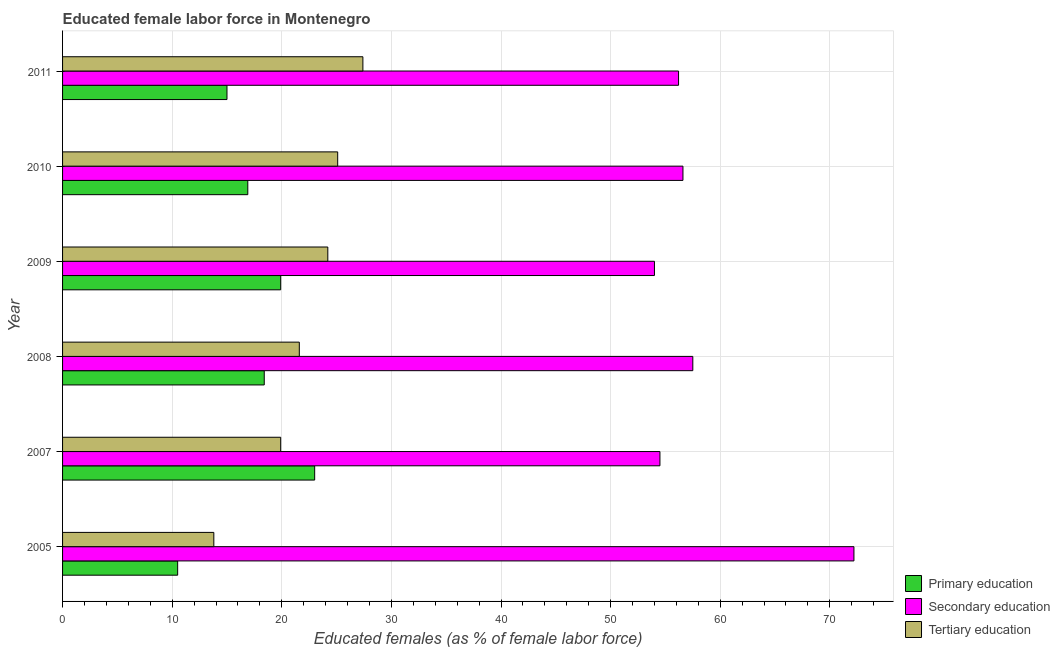How many different coloured bars are there?
Your answer should be compact. 3. How many bars are there on the 6th tick from the bottom?
Provide a succinct answer. 3. In how many cases, is the number of bars for a given year not equal to the number of legend labels?
Ensure brevity in your answer.  0. What is the percentage of female labor force who received tertiary education in 2005?
Provide a short and direct response. 13.8. Across all years, what is the maximum percentage of female labor force who received tertiary education?
Your response must be concise. 27.4. Across all years, what is the minimum percentage of female labor force who received secondary education?
Make the answer very short. 54. In which year was the percentage of female labor force who received secondary education minimum?
Provide a succinct answer. 2009. What is the total percentage of female labor force who received primary education in the graph?
Make the answer very short. 103.7. What is the difference between the percentage of female labor force who received tertiary education in 2005 and that in 2009?
Offer a very short reply. -10.4. What is the difference between the percentage of female labor force who received tertiary education in 2011 and the percentage of female labor force who received primary education in 2010?
Keep it short and to the point. 10.5. What is the average percentage of female labor force who received primary education per year?
Your answer should be compact. 17.28. In the year 2007, what is the difference between the percentage of female labor force who received primary education and percentage of female labor force who received tertiary education?
Offer a terse response. 3.1. Is the percentage of female labor force who received primary education in 2010 less than that in 2011?
Give a very brief answer. No. Is the difference between the percentage of female labor force who received tertiary education in 2007 and 2010 greater than the difference between the percentage of female labor force who received primary education in 2007 and 2010?
Your answer should be compact. No. What is the difference between the highest and the second highest percentage of female labor force who received primary education?
Keep it short and to the point. 3.1. What is the difference between the highest and the lowest percentage of female labor force who received secondary education?
Make the answer very short. 18.2. In how many years, is the percentage of female labor force who received secondary education greater than the average percentage of female labor force who received secondary education taken over all years?
Ensure brevity in your answer.  1. What does the 2nd bar from the top in 2008 represents?
Keep it short and to the point. Secondary education. What does the 2nd bar from the bottom in 2008 represents?
Provide a succinct answer. Secondary education. Is it the case that in every year, the sum of the percentage of female labor force who received primary education and percentage of female labor force who received secondary education is greater than the percentage of female labor force who received tertiary education?
Offer a very short reply. Yes. How many bars are there?
Offer a terse response. 18. Are all the bars in the graph horizontal?
Your answer should be compact. Yes. How many years are there in the graph?
Ensure brevity in your answer.  6. Are the values on the major ticks of X-axis written in scientific E-notation?
Keep it short and to the point. No. Does the graph contain grids?
Ensure brevity in your answer.  Yes. How are the legend labels stacked?
Give a very brief answer. Vertical. What is the title of the graph?
Offer a terse response. Educated female labor force in Montenegro. Does "Central government" appear as one of the legend labels in the graph?
Offer a very short reply. No. What is the label or title of the X-axis?
Make the answer very short. Educated females (as % of female labor force). What is the label or title of the Y-axis?
Give a very brief answer. Year. What is the Educated females (as % of female labor force) of Secondary education in 2005?
Give a very brief answer. 72.2. What is the Educated females (as % of female labor force) of Tertiary education in 2005?
Offer a terse response. 13.8. What is the Educated females (as % of female labor force) of Secondary education in 2007?
Give a very brief answer. 54.5. What is the Educated females (as % of female labor force) in Tertiary education in 2007?
Offer a very short reply. 19.9. What is the Educated females (as % of female labor force) of Primary education in 2008?
Provide a succinct answer. 18.4. What is the Educated females (as % of female labor force) of Secondary education in 2008?
Offer a very short reply. 57.5. What is the Educated females (as % of female labor force) in Tertiary education in 2008?
Your answer should be very brief. 21.6. What is the Educated females (as % of female labor force) of Primary education in 2009?
Your response must be concise. 19.9. What is the Educated females (as % of female labor force) in Secondary education in 2009?
Your answer should be compact. 54. What is the Educated females (as % of female labor force) of Tertiary education in 2009?
Provide a short and direct response. 24.2. What is the Educated females (as % of female labor force) of Primary education in 2010?
Provide a short and direct response. 16.9. What is the Educated females (as % of female labor force) in Secondary education in 2010?
Keep it short and to the point. 56.6. What is the Educated females (as % of female labor force) in Tertiary education in 2010?
Provide a succinct answer. 25.1. What is the Educated females (as % of female labor force) of Primary education in 2011?
Offer a very short reply. 15. What is the Educated females (as % of female labor force) of Secondary education in 2011?
Keep it short and to the point. 56.2. What is the Educated females (as % of female labor force) in Tertiary education in 2011?
Offer a terse response. 27.4. Across all years, what is the maximum Educated females (as % of female labor force) in Primary education?
Provide a succinct answer. 23. Across all years, what is the maximum Educated females (as % of female labor force) in Secondary education?
Provide a succinct answer. 72.2. Across all years, what is the maximum Educated females (as % of female labor force) of Tertiary education?
Ensure brevity in your answer.  27.4. Across all years, what is the minimum Educated females (as % of female labor force) in Primary education?
Provide a short and direct response. 10.5. Across all years, what is the minimum Educated females (as % of female labor force) in Tertiary education?
Provide a short and direct response. 13.8. What is the total Educated females (as % of female labor force) in Primary education in the graph?
Your answer should be very brief. 103.7. What is the total Educated females (as % of female labor force) of Secondary education in the graph?
Your answer should be very brief. 351. What is the total Educated females (as % of female labor force) in Tertiary education in the graph?
Keep it short and to the point. 132. What is the difference between the Educated females (as % of female labor force) in Primary education in 2005 and that in 2007?
Provide a short and direct response. -12.5. What is the difference between the Educated females (as % of female labor force) in Secondary education in 2005 and that in 2008?
Your response must be concise. 14.7. What is the difference between the Educated females (as % of female labor force) in Tertiary education in 2005 and that in 2008?
Offer a very short reply. -7.8. What is the difference between the Educated females (as % of female labor force) of Secondary education in 2005 and that in 2009?
Keep it short and to the point. 18.2. What is the difference between the Educated females (as % of female labor force) in Primary education in 2005 and that in 2010?
Your answer should be very brief. -6.4. What is the difference between the Educated females (as % of female labor force) in Secondary education in 2005 and that in 2010?
Your response must be concise. 15.6. What is the difference between the Educated females (as % of female labor force) in Tertiary education in 2005 and that in 2010?
Provide a succinct answer. -11.3. What is the difference between the Educated females (as % of female labor force) of Secondary education in 2005 and that in 2011?
Provide a succinct answer. 16. What is the difference between the Educated females (as % of female labor force) in Tertiary education in 2005 and that in 2011?
Offer a terse response. -13.6. What is the difference between the Educated females (as % of female labor force) of Primary education in 2007 and that in 2008?
Keep it short and to the point. 4.6. What is the difference between the Educated females (as % of female labor force) of Primary education in 2007 and that in 2009?
Offer a very short reply. 3.1. What is the difference between the Educated females (as % of female labor force) of Secondary education in 2007 and that in 2009?
Provide a succinct answer. 0.5. What is the difference between the Educated females (as % of female labor force) in Primary education in 2007 and that in 2010?
Keep it short and to the point. 6.1. What is the difference between the Educated females (as % of female labor force) of Secondary education in 2007 and that in 2010?
Your response must be concise. -2.1. What is the difference between the Educated females (as % of female labor force) in Secondary education in 2007 and that in 2011?
Give a very brief answer. -1.7. What is the difference between the Educated females (as % of female labor force) in Primary education in 2008 and that in 2009?
Your answer should be very brief. -1.5. What is the difference between the Educated females (as % of female labor force) in Secondary education in 2008 and that in 2009?
Provide a succinct answer. 3.5. What is the difference between the Educated females (as % of female labor force) in Primary education in 2008 and that in 2010?
Keep it short and to the point. 1.5. What is the difference between the Educated females (as % of female labor force) in Secondary education in 2008 and that in 2010?
Ensure brevity in your answer.  0.9. What is the difference between the Educated females (as % of female labor force) of Primary education in 2008 and that in 2011?
Offer a terse response. 3.4. What is the difference between the Educated females (as % of female labor force) in Tertiary education in 2008 and that in 2011?
Provide a succinct answer. -5.8. What is the difference between the Educated females (as % of female labor force) of Primary education in 2009 and that in 2010?
Offer a terse response. 3. What is the difference between the Educated females (as % of female labor force) of Secondary education in 2009 and that in 2010?
Give a very brief answer. -2.6. What is the difference between the Educated females (as % of female labor force) in Tertiary education in 2009 and that in 2010?
Offer a terse response. -0.9. What is the difference between the Educated females (as % of female labor force) of Tertiary education in 2009 and that in 2011?
Provide a succinct answer. -3.2. What is the difference between the Educated females (as % of female labor force) of Primary education in 2010 and that in 2011?
Keep it short and to the point. 1.9. What is the difference between the Educated females (as % of female labor force) in Secondary education in 2010 and that in 2011?
Your answer should be compact. 0.4. What is the difference between the Educated females (as % of female labor force) of Primary education in 2005 and the Educated females (as % of female labor force) of Secondary education in 2007?
Keep it short and to the point. -44. What is the difference between the Educated females (as % of female labor force) of Primary education in 2005 and the Educated females (as % of female labor force) of Tertiary education in 2007?
Your answer should be very brief. -9.4. What is the difference between the Educated females (as % of female labor force) in Secondary education in 2005 and the Educated females (as % of female labor force) in Tertiary education in 2007?
Your answer should be compact. 52.3. What is the difference between the Educated females (as % of female labor force) of Primary education in 2005 and the Educated females (as % of female labor force) of Secondary education in 2008?
Keep it short and to the point. -47. What is the difference between the Educated females (as % of female labor force) of Primary education in 2005 and the Educated females (as % of female labor force) of Tertiary education in 2008?
Offer a very short reply. -11.1. What is the difference between the Educated females (as % of female labor force) in Secondary education in 2005 and the Educated females (as % of female labor force) in Tertiary education in 2008?
Keep it short and to the point. 50.6. What is the difference between the Educated females (as % of female labor force) in Primary education in 2005 and the Educated females (as % of female labor force) in Secondary education in 2009?
Provide a succinct answer. -43.5. What is the difference between the Educated females (as % of female labor force) of Primary education in 2005 and the Educated females (as % of female labor force) of Tertiary education in 2009?
Provide a short and direct response. -13.7. What is the difference between the Educated females (as % of female labor force) in Primary education in 2005 and the Educated females (as % of female labor force) in Secondary education in 2010?
Your answer should be compact. -46.1. What is the difference between the Educated females (as % of female labor force) of Primary education in 2005 and the Educated females (as % of female labor force) of Tertiary education in 2010?
Provide a succinct answer. -14.6. What is the difference between the Educated females (as % of female labor force) of Secondary education in 2005 and the Educated females (as % of female labor force) of Tertiary education in 2010?
Your answer should be compact. 47.1. What is the difference between the Educated females (as % of female labor force) in Primary education in 2005 and the Educated females (as % of female labor force) in Secondary education in 2011?
Your response must be concise. -45.7. What is the difference between the Educated females (as % of female labor force) in Primary education in 2005 and the Educated females (as % of female labor force) in Tertiary education in 2011?
Provide a short and direct response. -16.9. What is the difference between the Educated females (as % of female labor force) of Secondary education in 2005 and the Educated females (as % of female labor force) of Tertiary education in 2011?
Give a very brief answer. 44.8. What is the difference between the Educated females (as % of female labor force) of Primary education in 2007 and the Educated females (as % of female labor force) of Secondary education in 2008?
Your answer should be very brief. -34.5. What is the difference between the Educated females (as % of female labor force) in Secondary education in 2007 and the Educated females (as % of female labor force) in Tertiary education in 2008?
Give a very brief answer. 32.9. What is the difference between the Educated females (as % of female labor force) in Primary education in 2007 and the Educated females (as % of female labor force) in Secondary education in 2009?
Give a very brief answer. -31. What is the difference between the Educated females (as % of female labor force) of Primary education in 2007 and the Educated females (as % of female labor force) of Tertiary education in 2009?
Offer a very short reply. -1.2. What is the difference between the Educated females (as % of female labor force) in Secondary education in 2007 and the Educated females (as % of female labor force) in Tertiary education in 2009?
Ensure brevity in your answer.  30.3. What is the difference between the Educated females (as % of female labor force) in Primary education in 2007 and the Educated females (as % of female labor force) in Secondary education in 2010?
Offer a very short reply. -33.6. What is the difference between the Educated females (as % of female labor force) in Primary education in 2007 and the Educated females (as % of female labor force) in Tertiary education in 2010?
Make the answer very short. -2.1. What is the difference between the Educated females (as % of female labor force) in Secondary education in 2007 and the Educated females (as % of female labor force) in Tertiary education in 2010?
Ensure brevity in your answer.  29.4. What is the difference between the Educated females (as % of female labor force) of Primary education in 2007 and the Educated females (as % of female labor force) of Secondary education in 2011?
Keep it short and to the point. -33.2. What is the difference between the Educated females (as % of female labor force) in Secondary education in 2007 and the Educated females (as % of female labor force) in Tertiary education in 2011?
Offer a very short reply. 27.1. What is the difference between the Educated females (as % of female labor force) of Primary education in 2008 and the Educated females (as % of female labor force) of Secondary education in 2009?
Your answer should be compact. -35.6. What is the difference between the Educated females (as % of female labor force) in Secondary education in 2008 and the Educated females (as % of female labor force) in Tertiary education in 2009?
Your response must be concise. 33.3. What is the difference between the Educated females (as % of female labor force) of Primary education in 2008 and the Educated females (as % of female labor force) of Secondary education in 2010?
Your answer should be very brief. -38.2. What is the difference between the Educated females (as % of female labor force) in Primary education in 2008 and the Educated females (as % of female labor force) in Tertiary education in 2010?
Make the answer very short. -6.7. What is the difference between the Educated females (as % of female labor force) of Secondary education in 2008 and the Educated females (as % of female labor force) of Tertiary education in 2010?
Give a very brief answer. 32.4. What is the difference between the Educated females (as % of female labor force) in Primary education in 2008 and the Educated females (as % of female labor force) in Secondary education in 2011?
Provide a succinct answer. -37.8. What is the difference between the Educated females (as % of female labor force) of Primary education in 2008 and the Educated females (as % of female labor force) of Tertiary education in 2011?
Your response must be concise. -9. What is the difference between the Educated females (as % of female labor force) in Secondary education in 2008 and the Educated females (as % of female labor force) in Tertiary education in 2011?
Provide a succinct answer. 30.1. What is the difference between the Educated females (as % of female labor force) in Primary education in 2009 and the Educated females (as % of female labor force) in Secondary education in 2010?
Offer a very short reply. -36.7. What is the difference between the Educated females (as % of female labor force) of Secondary education in 2009 and the Educated females (as % of female labor force) of Tertiary education in 2010?
Offer a very short reply. 28.9. What is the difference between the Educated females (as % of female labor force) in Primary education in 2009 and the Educated females (as % of female labor force) in Secondary education in 2011?
Ensure brevity in your answer.  -36.3. What is the difference between the Educated females (as % of female labor force) in Secondary education in 2009 and the Educated females (as % of female labor force) in Tertiary education in 2011?
Your response must be concise. 26.6. What is the difference between the Educated females (as % of female labor force) in Primary education in 2010 and the Educated females (as % of female labor force) in Secondary education in 2011?
Give a very brief answer. -39.3. What is the difference between the Educated females (as % of female labor force) of Secondary education in 2010 and the Educated females (as % of female labor force) of Tertiary education in 2011?
Your answer should be compact. 29.2. What is the average Educated females (as % of female labor force) of Primary education per year?
Offer a terse response. 17.28. What is the average Educated females (as % of female labor force) of Secondary education per year?
Ensure brevity in your answer.  58.5. In the year 2005, what is the difference between the Educated females (as % of female labor force) of Primary education and Educated females (as % of female labor force) of Secondary education?
Provide a succinct answer. -61.7. In the year 2005, what is the difference between the Educated females (as % of female labor force) of Secondary education and Educated females (as % of female labor force) of Tertiary education?
Keep it short and to the point. 58.4. In the year 2007, what is the difference between the Educated females (as % of female labor force) in Primary education and Educated females (as % of female labor force) in Secondary education?
Your answer should be very brief. -31.5. In the year 2007, what is the difference between the Educated females (as % of female labor force) in Secondary education and Educated females (as % of female labor force) in Tertiary education?
Keep it short and to the point. 34.6. In the year 2008, what is the difference between the Educated females (as % of female labor force) in Primary education and Educated females (as % of female labor force) in Secondary education?
Your response must be concise. -39.1. In the year 2008, what is the difference between the Educated females (as % of female labor force) in Secondary education and Educated females (as % of female labor force) in Tertiary education?
Offer a very short reply. 35.9. In the year 2009, what is the difference between the Educated females (as % of female labor force) in Primary education and Educated females (as % of female labor force) in Secondary education?
Offer a very short reply. -34.1. In the year 2009, what is the difference between the Educated females (as % of female labor force) of Secondary education and Educated females (as % of female labor force) of Tertiary education?
Make the answer very short. 29.8. In the year 2010, what is the difference between the Educated females (as % of female labor force) in Primary education and Educated females (as % of female labor force) in Secondary education?
Offer a terse response. -39.7. In the year 2010, what is the difference between the Educated females (as % of female labor force) in Secondary education and Educated females (as % of female labor force) in Tertiary education?
Keep it short and to the point. 31.5. In the year 2011, what is the difference between the Educated females (as % of female labor force) of Primary education and Educated females (as % of female labor force) of Secondary education?
Your answer should be compact. -41.2. In the year 2011, what is the difference between the Educated females (as % of female labor force) in Secondary education and Educated females (as % of female labor force) in Tertiary education?
Your answer should be very brief. 28.8. What is the ratio of the Educated females (as % of female labor force) in Primary education in 2005 to that in 2007?
Your answer should be very brief. 0.46. What is the ratio of the Educated females (as % of female labor force) of Secondary education in 2005 to that in 2007?
Ensure brevity in your answer.  1.32. What is the ratio of the Educated females (as % of female labor force) in Tertiary education in 2005 to that in 2007?
Your answer should be compact. 0.69. What is the ratio of the Educated females (as % of female labor force) in Primary education in 2005 to that in 2008?
Offer a very short reply. 0.57. What is the ratio of the Educated females (as % of female labor force) in Secondary education in 2005 to that in 2008?
Provide a short and direct response. 1.26. What is the ratio of the Educated females (as % of female labor force) of Tertiary education in 2005 to that in 2008?
Your response must be concise. 0.64. What is the ratio of the Educated females (as % of female labor force) in Primary education in 2005 to that in 2009?
Your answer should be compact. 0.53. What is the ratio of the Educated females (as % of female labor force) in Secondary education in 2005 to that in 2009?
Offer a terse response. 1.34. What is the ratio of the Educated females (as % of female labor force) of Tertiary education in 2005 to that in 2009?
Give a very brief answer. 0.57. What is the ratio of the Educated females (as % of female labor force) of Primary education in 2005 to that in 2010?
Offer a terse response. 0.62. What is the ratio of the Educated females (as % of female labor force) of Secondary education in 2005 to that in 2010?
Offer a terse response. 1.28. What is the ratio of the Educated females (as % of female labor force) in Tertiary education in 2005 to that in 2010?
Offer a very short reply. 0.55. What is the ratio of the Educated females (as % of female labor force) in Secondary education in 2005 to that in 2011?
Provide a succinct answer. 1.28. What is the ratio of the Educated females (as % of female labor force) in Tertiary education in 2005 to that in 2011?
Your answer should be compact. 0.5. What is the ratio of the Educated females (as % of female labor force) in Primary education in 2007 to that in 2008?
Offer a very short reply. 1.25. What is the ratio of the Educated females (as % of female labor force) of Secondary education in 2007 to that in 2008?
Keep it short and to the point. 0.95. What is the ratio of the Educated females (as % of female labor force) of Tertiary education in 2007 to that in 2008?
Offer a terse response. 0.92. What is the ratio of the Educated females (as % of female labor force) in Primary education in 2007 to that in 2009?
Ensure brevity in your answer.  1.16. What is the ratio of the Educated females (as % of female labor force) in Secondary education in 2007 to that in 2009?
Ensure brevity in your answer.  1.01. What is the ratio of the Educated females (as % of female labor force) of Tertiary education in 2007 to that in 2009?
Offer a terse response. 0.82. What is the ratio of the Educated females (as % of female labor force) in Primary education in 2007 to that in 2010?
Provide a succinct answer. 1.36. What is the ratio of the Educated females (as % of female labor force) of Secondary education in 2007 to that in 2010?
Your answer should be very brief. 0.96. What is the ratio of the Educated females (as % of female labor force) of Tertiary education in 2007 to that in 2010?
Offer a very short reply. 0.79. What is the ratio of the Educated females (as % of female labor force) in Primary education in 2007 to that in 2011?
Your answer should be compact. 1.53. What is the ratio of the Educated females (as % of female labor force) in Secondary education in 2007 to that in 2011?
Give a very brief answer. 0.97. What is the ratio of the Educated females (as % of female labor force) in Tertiary education in 2007 to that in 2011?
Your response must be concise. 0.73. What is the ratio of the Educated females (as % of female labor force) of Primary education in 2008 to that in 2009?
Ensure brevity in your answer.  0.92. What is the ratio of the Educated females (as % of female labor force) of Secondary education in 2008 to that in 2009?
Your answer should be very brief. 1.06. What is the ratio of the Educated females (as % of female labor force) in Tertiary education in 2008 to that in 2009?
Make the answer very short. 0.89. What is the ratio of the Educated females (as % of female labor force) of Primary education in 2008 to that in 2010?
Provide a succinct answer. 1.09. What is the ratio of the Educated females (as % of female labor force) in Secondary education in 2008 to that in 2010?
Ensure brevity in your answer.  1.02. What is the ratio of the Educated females (as % of female labor force) of Tertiary education in 2008 to that in 2010?
Provide a succinct answer. 0.86. What is the ratio of the Educated females (as % of female labor force) in Primary education in 2008 to that in 2011?
Offer a terse response. 1.23. What is the ratio of the Educated females (as % of female labor force) of Secondary education in 2008 to that in 2011?
Keep it short and to the point. 1.02. What is the ratio of the Educated females (as % of female labor force) in Tertiary education in 2008 to that in 2011?
Your response must be concise. 0.79. What is the ratio of the Educated females (as % of female labor force) of Primary education in 2009 to that in 2010?
Your answer should be very brief. 1.18. What is the ratio of the Educated females (as % of female labor force) in Secondary education in 2009 to that in 2010?
Your answer should be very brief. 0.95. What is the ratio of the Educated females (as % of female labor force) in Tertiary education in 2009 to that in 2010?
Offer a terse response. 0.96. What is the ratio of the Educated females (as % of female labor force) of Primary education in 2009 to that in 2011?
Offer a very short reply. 1.33. What is the ratio of the Educated females (as % of female labor force) in Secondary education in 2009 to that in 2011?
Your answer should be very brief. 0.96. What is the ratio of the Educated females (as % of female labor force) in Tertiary education in 2009 to that in 2011?
Give a very brief answer. 0.88. What is the ratio of the Educated females (as % of female labor force) in Primary education in 2010 to that in 2011?
Give a very brief answer. 1.13. What is the ratio of the Educated females (as % of female labor force) in Secondary education in 2010 to that in 2011?
Give a very brief answer. 1.01. What is the ratio of the Educated females (as % of female labor force) of Tertiary education in 2010 to that in 2011?
Your response must be concise. 0.92. What is the difference between the highest and the second highest Educated females (as % of female labor force) in Primary education?
Offer a terse response. 3.1. What is the difference between the highest and the second highest Educated females (as % of female labor force) of Secondary education?
Your answer should be compact. 14.7. What is the difference between the highest and the second highest Educated females (as % of female labor force) of Tertiary education?
Offer a terse response. 2.3. What is the difference between the highest and the lowest Educated females (as % of female labor force) in Primary education?
Make the answer very short. 12.5. What is the difference between the highest and the lowest Educated females (as % of female labor force) in Secondary education?
Provide a succinct answer. 18.2. 